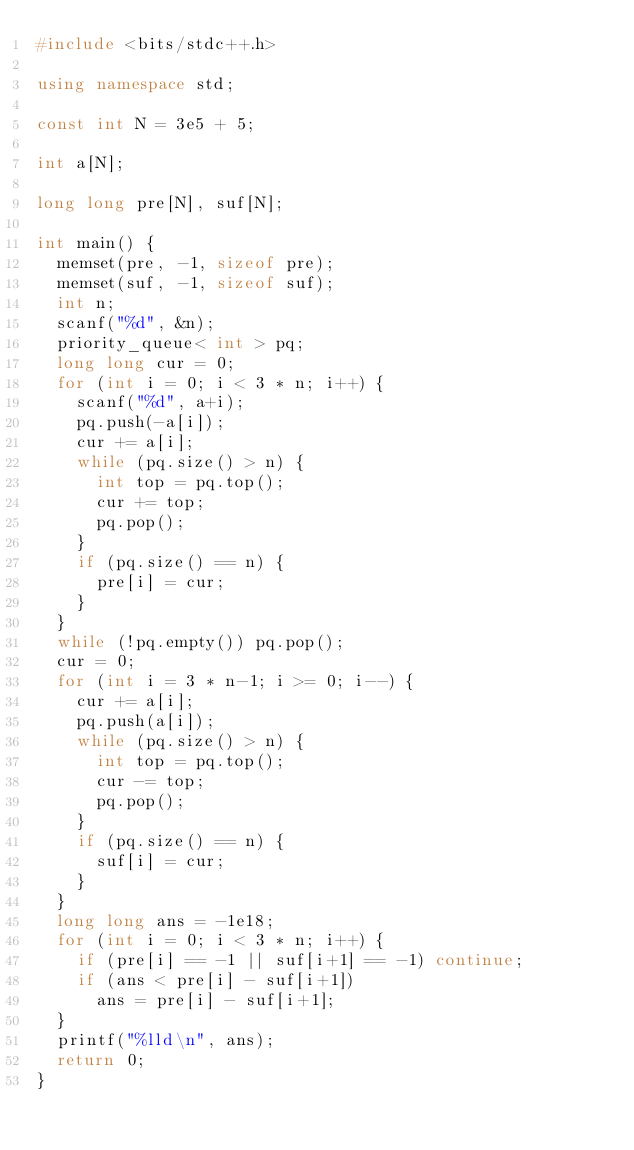<code> <loc_0><loc_0><loc_500><loc_500><_C++_>#include <bits/stdc++.h>

using namespace std;

const int N = 3e5 + 5;

int a[N];

long long pre[N], suf[N];

int main() {
  memset(pre, -1, sizeof pre);
  memset(suf, -1, sizeof suf);
  int n;
  scanf("%d", &n);
  priority_queue< int > pq;
  long long cur = 0;
  for (int i = 0; i < 3 * n; i++) {
    scanf("%d", a+i);
    pq.push(-a[i]);
    cur += a[i];
    while (pq.size() > n) {
      int top = pq.top();
      cur += top;
      pq.pop();
    }
    if (pq.size() == n) {
      pre[i] = cur;
    }
  }
  while (!pq.empty()) pq.pop();
  cur = 0;
  for (int i = 3 * n-1; i >= 0; i--) {
    cur += a[i];
    pq.push(a[i]);
    while (pq.size() > n) {
      int top = pq.top();
      cur -= top;
      pq.pop();
    }
    if (pq.size() == n) {
      suf[i] = cur;
    }
  }
  long long ans = -1e18;
  for (int i = 0; i < 3 * n; i++) {
    if (pre[i] == -1 || suf[i+1] == -1) continue;
    if (ans < pre[i] - suf[i+1])
      ans = pre[i] - suf[i+1];
  }
  printf("%lld\n", ans);
  return 0;
}</code> 